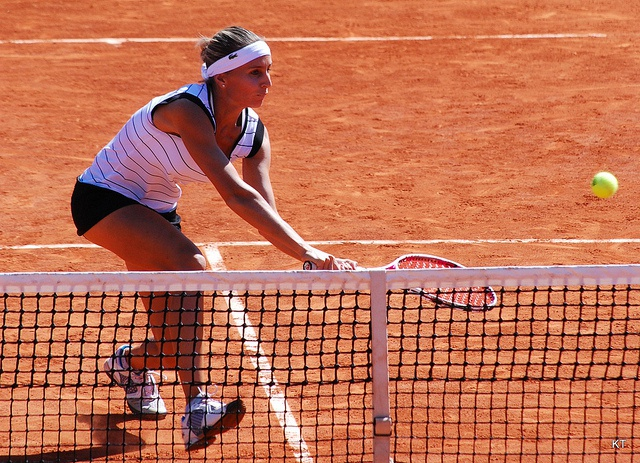Describe the objects in this image and their specific colors. I can see people in red, maroon, black, brown, and white tones, tennis racket in red, white, salmon, lightpink, and brown tones, and sports ball in red, orange, beige, olive, and khaki tones in this image. 